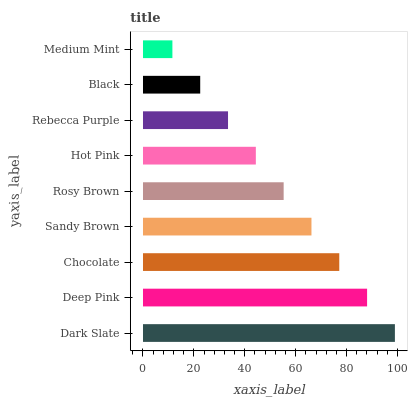Is Medium Mint the minimum?
Answer yes or no. Yes. Is Dark Slate the maximum?
Answer yes or no. Yes. Is Deep Pink the minimum?
Answer yes or no. No. Is Deep Pink the maximum?
Answer yes or no. No. Is Dark Slate greater than Deep Pink?
Answer yes or no. Yes. Is Deep Pink less than Dark Slate?
Answer yes or no. Yes. Is Deep Pink greater than Dark Slate?
Answer yes or no. No. Is Dark Slate less than Deep Pink?
Answer yes or no. No. Is Rosy Brown the high median?
Answer yes or no. Yes. Is Rosy Brown the low median?
Answer yes or no. Yes. Is Dark Slate the high median?
Answer yes or no. No. Is Dark Slate the low median?
Answer yes or no. No. 